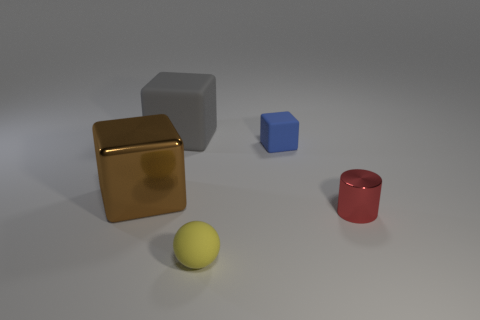Subtract all gray rubber cubes. How many cubes are left? 2 Add 1 yellow metal things. How many objects exist? 6 Subtract 1 blocks. How many blocks are left? 2 Subtract all purple blocks. Subtract all purple cylinders. How many blocks are left? 3 Add 4 blue shiny cylinders. How many blue shiny cylinders exist? 4 Subtract 1 red cylinders. How many objects are left? 4 Subtract all cubes. How many objects are left? 2 Subtract all gray blocks. Subtract all yellow rubber things. How many objects are left? 3 Add 1 small shiny objects. How many small shiny objects are left? 2 